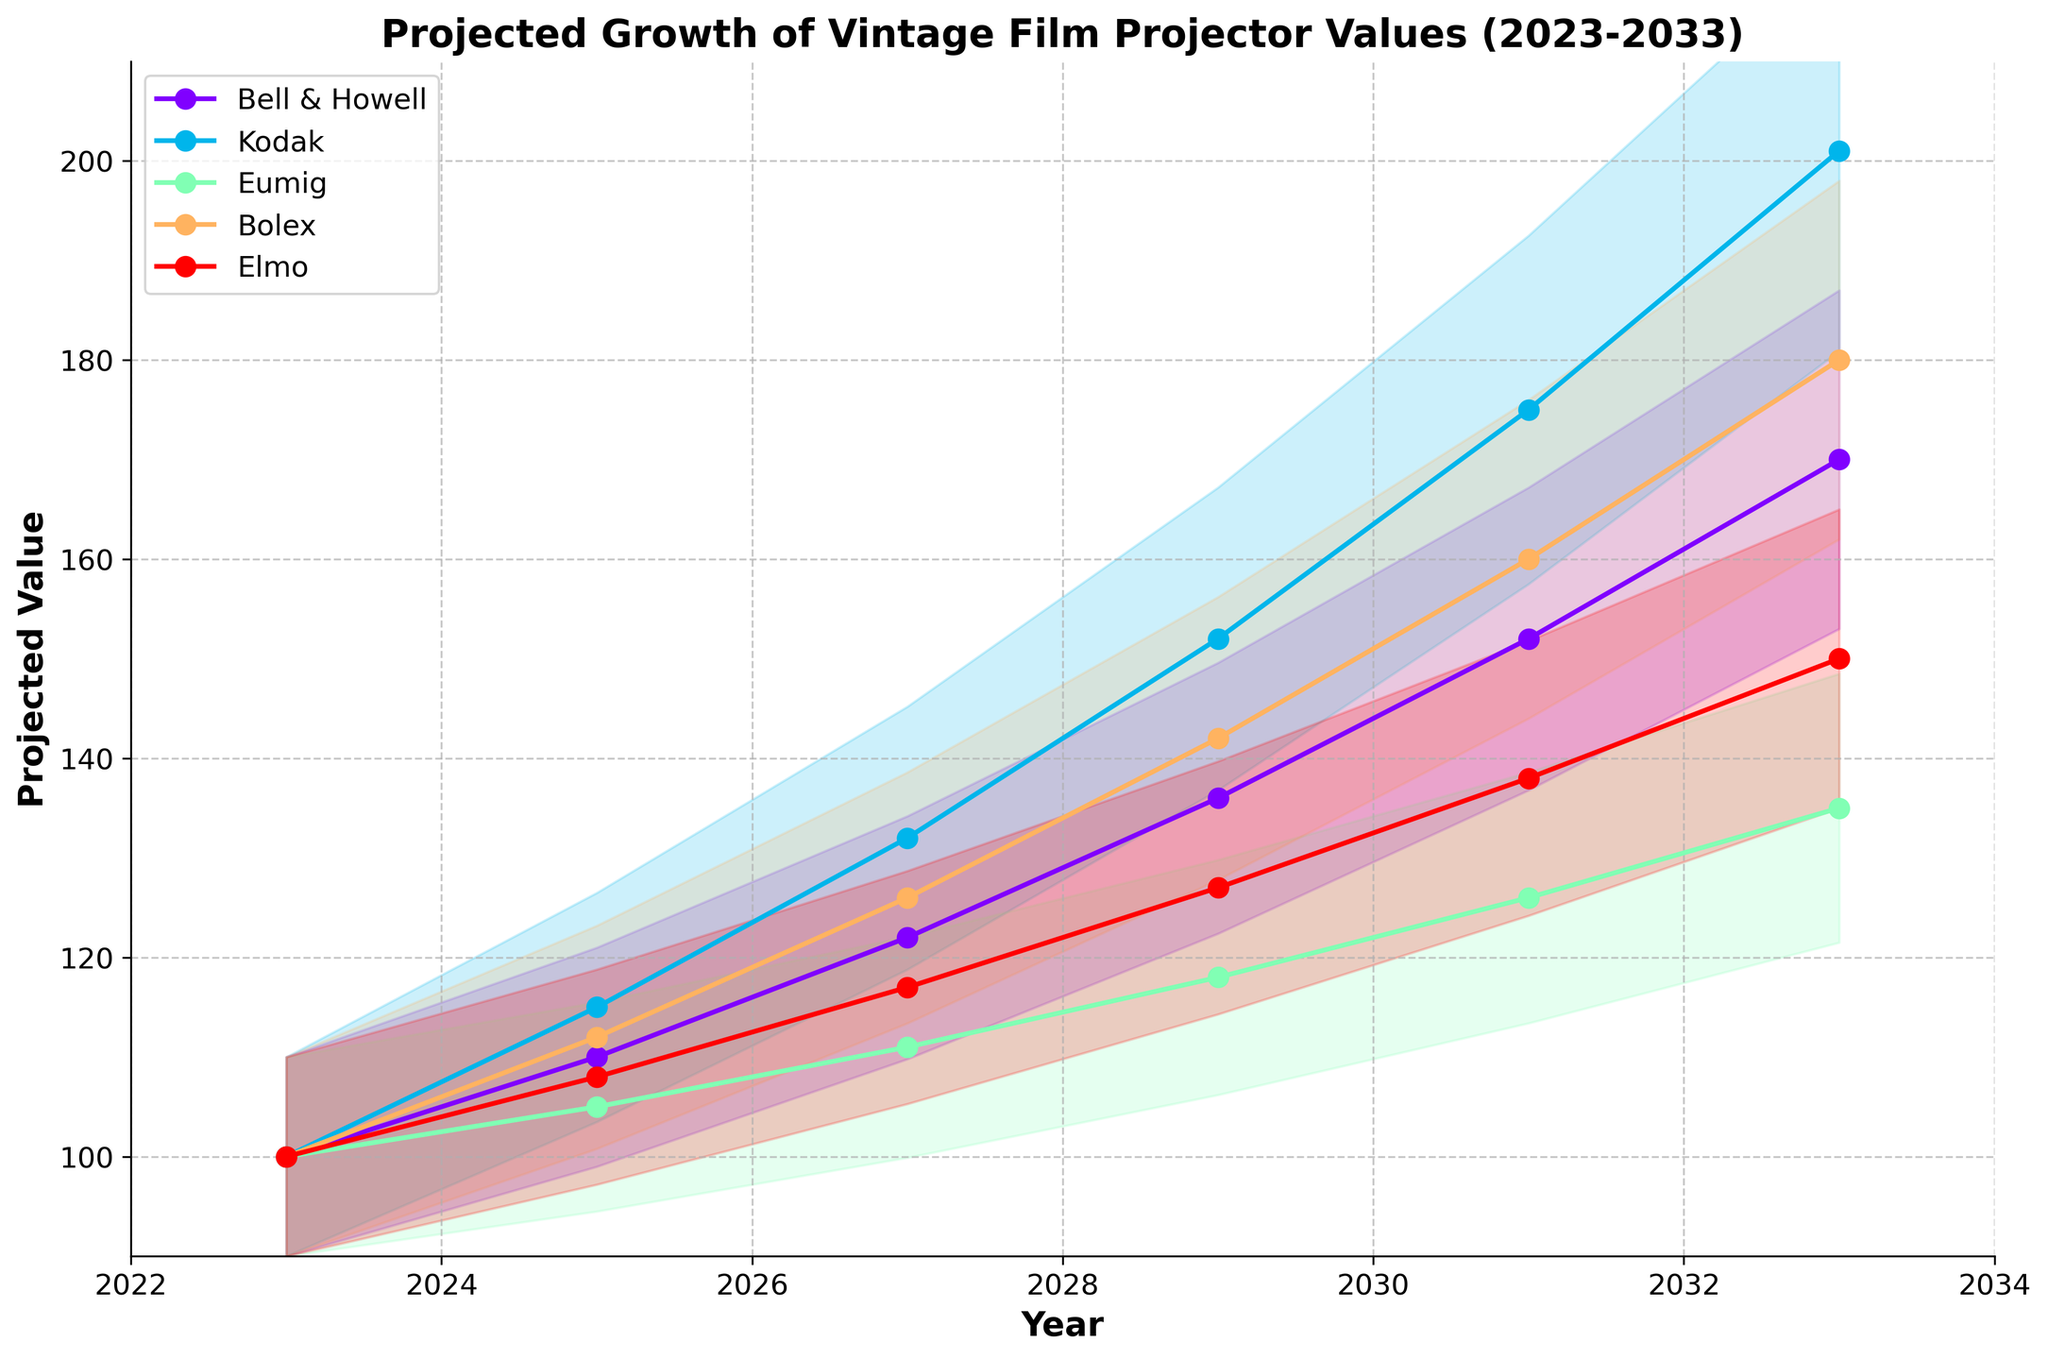What is the title of the figure? The title of the figure is found at the top and it summarizes the purpose of the plot, which is about predicting future values of vintage film projectors.
Answer: Projected Growth of Vintage Film Projector Values (2023-2033) Which brand has the highest projected value in 2033? Looking at the projected values for 2033, the highest value line can be identified visually among the different colored lines or by reading the data.
Answer: Kodak What is the projected value of Bolex in 2029? The line corresponding to Bolex in 2029 can be located, or the point can be read directly from the given data.
Answer: 142 Which brand shows the lowest projected value in 2027? Observing the graph or checking the data values for 2027, the line with the lowest point will show the brand with the smallest value.
Answer: Eumig How does the projected value of Elmo change from 2023 to 2033? To determine the change, subtract the projected value in 2023 from that in 2033.
Answer: 50 By how much is Kodak's projected value expected to increase between 2023 and 2033? Look at the value for Kodak in 2033 and subtract the value for 2023 from it.
Answer: 101 Which brand demonstrates the most significant growth in projected value over the entire period? Compare the growth of each brand by subtracting their starting values in 2023 from their projected values in 2033 and see which is the largest.
Answer: Kodak Between which years does Bell & Howell show the highest increase in value? Calculate the increase in Bell & Howell's value between each set of consecutive years and identify the largest increase.
Answer: 2029 to 2031 Compare the projected values of Eumig and Elmo in 2025. Which one is higher? Locate the values for both Eumig and Elmo for 2025 and compare them.
Answer: Elmo By how much is the projected value of Bolex expected to increase from 2025 to 2027? Subtract the projected value of Bolex in 2025 from that in 2027.
Answer: 14 